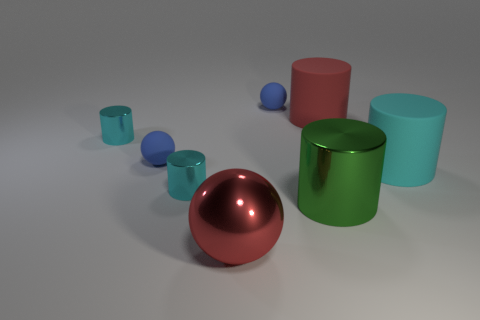Do the ball behind the large red matte cylinder and the rubber sphere that is in front of the big red rubber thing have the same color?
Ensure brevity in your answer.  Yes. What shape is the large cyan object that is the same material as the red cylinder?
Keep it short and to the point. Cylinder. Are there fewer green objects that are in front of the big green thing than red objects that are in front of the big red rubber thing?
Provide a short and direct response. Yes. What number of small objects are either red matte cylinders or yellow cubes?
Your answer should be very brief. 0. There is a shiny thing behind the large cyan object; does it have the same shape as the large green shiny object that is in front of the cyan rubber thing?
Offer a terse response. Yes. There is a red matte object behind the ball that is in front of the tiny blue sphere that is in front of the big red matte object; what size is it?
Offer a very short reply. Large. What is the size of the matte cylinder that is in front of the big red cylinder?
Your answer should be compact. Large. There is a red thing that is right of the big green metallic thing; what is it made of?
Provide a short and direct response. Rubber. What number of purple things are small matte things or spheres?
Offer a very short reply. 0. Does the big red cylinder have the same material as the sphere in front of the big cyan rubber thing?
Keep it short and to the point. No. 